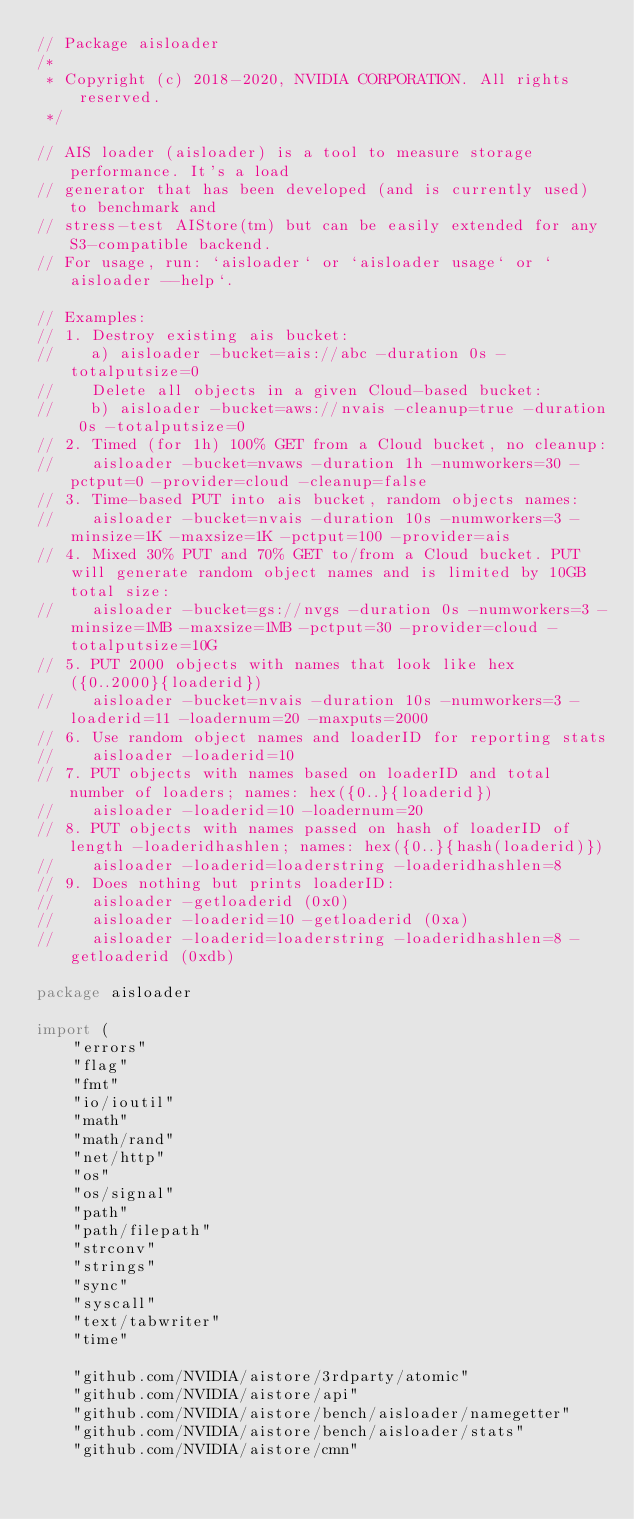Convert code to text. <code><loc_0><loc_0><loc_500><loc_500><_Go_>// Package aisloader
/*
 * Copyright (c) 2018-2020, NVIDIA CORPORATION. All rights reserved.
 */

// AIS loader (aisloader) is a tool to measure storage performance. It's a load
// generator that has been developed (and is currently used) to benchmark and
// stress-test AIStore(tm) but can be easily extended for any S3-compatible backend.
// For usage, run: `aisloader` or `aisloader usage` or `aisloader --help`.

// Examples:
// 1. Destroy existing ais bucket:
//    a) aisloader -bucket=ais://abc -duration 0s -totalputsize=0
//    Delete all objects in a given Cloud-based bucket:
//    b) aisloader -bucket=aws://nvais -cleanup=true -duration 0s -totalputsize=0
// 2. Timed (for 1h) 100% GET from a Cloud bucket, no cleanup:
//    aisloader -bucket=nvaws -duration 1h -numworkers=30 -pctput=0 -provider=cloud -cleanup=false
// 3. Time-based PUT into ais bucket, random objects names:
//    aisloader -bucket=nvais -duration 10s -numworkers=3 -minsize=1K -maxsize=1K -pctput=100 -provider=ais
// 4. Mixed 30% PUT and 70% GET to/from a Cloud bucket. PUT will generate random object names and is limited by 10GB total size:
//    aisloader -bucket=gs://nvgs -duration 0s -numworkers=3 -minsize=1MB -maxsize=1MB -pctput=30 -provider=cloud -totalputsize=10G
// 5. PUT 2000 objects with names that look like hex({0..2000}{loaderid})
//    aisloader -bucket=nvais -duration 10s -numworkers=3 -loaderid=11 -loadernum=20 -maxputs=2000
// 6. Use random object names and loaderID for reporting stats
//    aisloader -loaderid=10
// 7. PUT objects with names based on loaderID and total number of loaders; names: hex({0..}{loaderid})
//    aisloader -loaderid=10 -loadernum=20
// 8. PUT objects with names passed on hash of loaderID of length -loaderidhashlen; names: hex({0..}{hash(loaderid)})
//    aisloader -loaderid=loaderstring -loaderidhashlen=8
// 9. Does nothing but prints loaderID:
//    aisloader -getloaderid (0x0)
//    aisloader -loaderid=10 -getloaderid (0xa)
//    aisloader -loaderid=loaderstring -loaderidhashlen=8 -getloaderid (0xdb)

package aisloader

import (
	"errors"
	"flag"
	"fmt"
	"io/ioutil"
	"math"
	"math/rand"
	"net/http"
	"os"
	"os/signal"
	"path"
	"path/filepath"
	"strconv"
	"strings"
	"sync"
	"syscall"
	"text/tabwriter"
	"time"

	"github.com/NVIDIA/aistore/3rdparty/atomic"
	"github.com/NVIDIA/aistore/api"
	"github.com/NVIDIA/aistore/bench/aisloader/namegetter"
	"github.com/NVIDIA/aistore/bench/aisloader/stats"
	"github.com/NVIDIA/aistore/cmn"</code> 